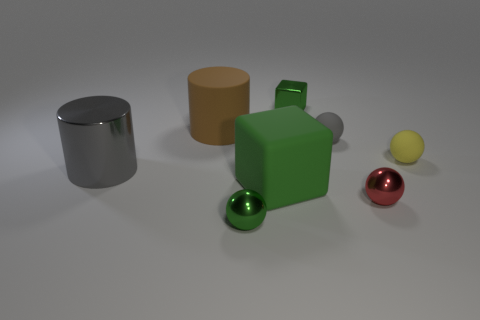The metallic object that is behind the yellow thing that is to the right of the rubber block is what shape? The object you're inquiring about has a cylindrical shape. It features a reflective metallic surface that distinguishes it from the other colorful, matte objects in the scene. 